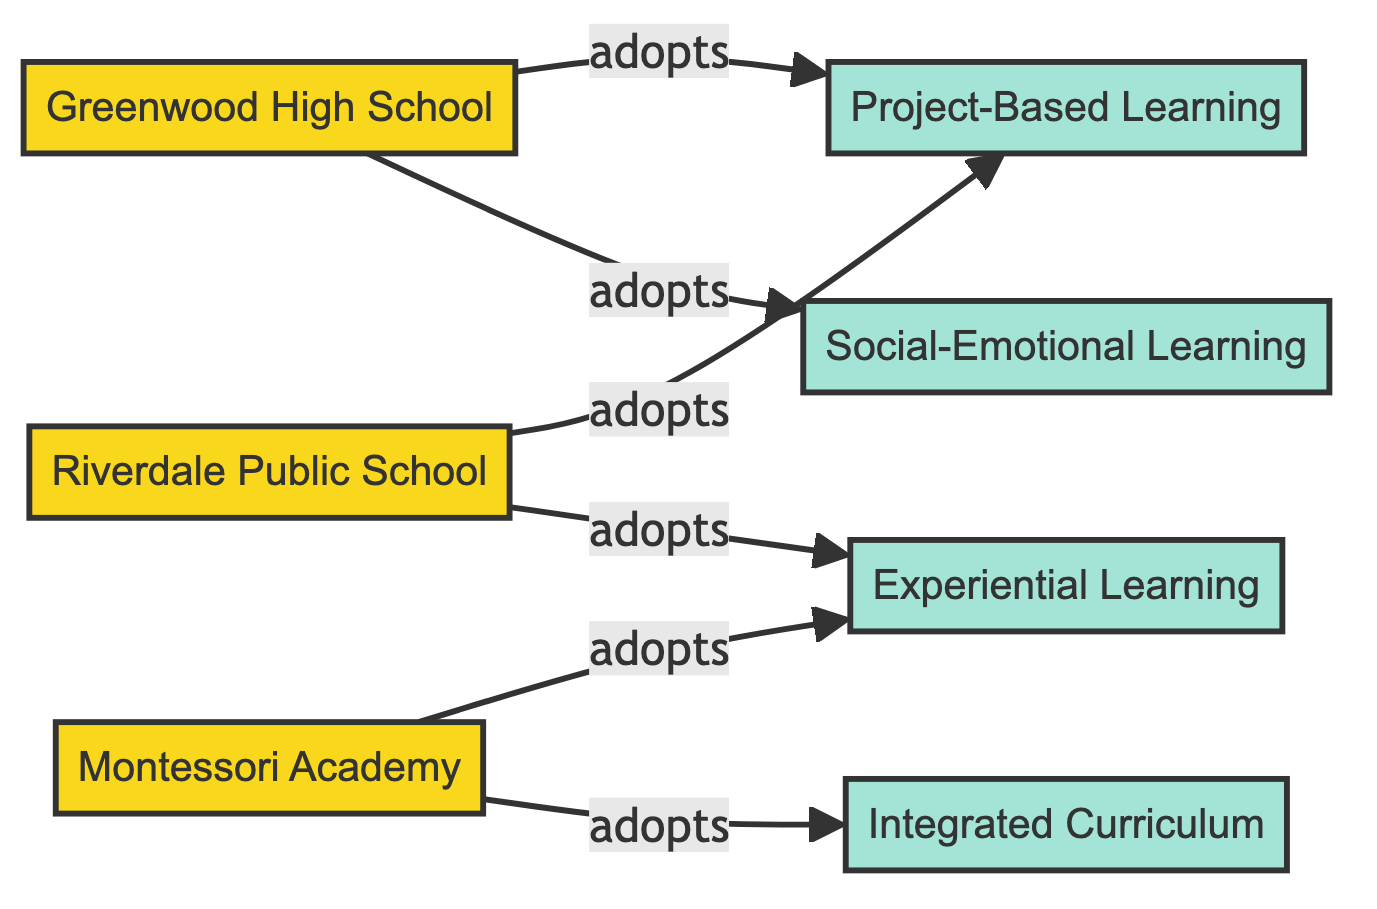What institutions are adopting Social-Emotional Learning? To answer this, we can look at the edges that connect nodes representing institutions to the "Social-Emotional Learning" practice node. The edges show that "Greenwood High School" directly connects to "Social-Emotional Learning," indicating that it adopts this educational practice. Therefore, the only institution adopting it is "Greenwood High School."
Answer: Greenwood High School How many educational practices are adopted by Greenwood High School? By examining the edges emanating from the "Greenwood High School" node, we can count the connections it has to educational practices. It has edges to "Project-Based Learning" and "Social-Emotional Learning," totaling two educational practices.
Answer: 2 Which school adopts Experiential Learning? We can look for the nodes that directly connect with "Experiential Learning." The edges in the diagram show that both "Montessori Academy" and "Riverdale Public School" connect to this practice, indicating they both adopt it.
Answer: Montessori Academy, Riverdale Public School How many nodes represent educational practices in this diagram? By reviewing the nodes listed, we can identify those that represent educational practices. There are four educational practices: "Project-Based Learning," "Social-Emotional Learning," "Experiential Learning," and "Integrated Curriculum." Thus, there are four nodes for educational practices.
Answer: 4 Which institution adopts more educational practices? We need to compare the number of edges connecting each institution to educational practices. "Greenwood High School" has two edges, "Montessori Academy" has two edges, and "Riverdale Public School" has two edges. Therefore, all institutions adopt the same number of educational practices.
Answer: All institutions (Greenwood High School, Montessori Academy, Riverdale Public School) 